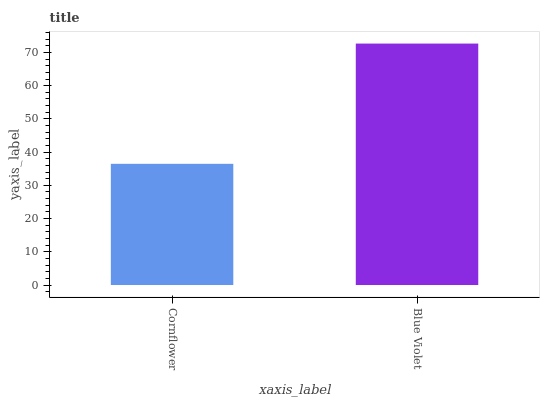Is Cornflower the minimum?
Answer yes or no. Yes. Is Blue Violet the maximum?
Answer yes or no. Yes. Is Blue Violet the minimum?
Answer yes or no. No. Is Blue Violet greater than Cornflower?
Answer yes or no. Yes. Is Cornflower less than Blue Violet?
Answer yes or no. Yes. Is Cornflower greater than Blue Violet?
Answer yes or no. No. Is Blue Violet less than Cornflower?
Answer yes or no. No. Is Blue Violet the high median?
Answer yes or no. Yes. Is Cornflower the low median?
Answer yes or no. Yes. Is Cornflower the high median?
Answer yes or no. No. Is Blue Violet the low median?
Answer yes or no. No. 